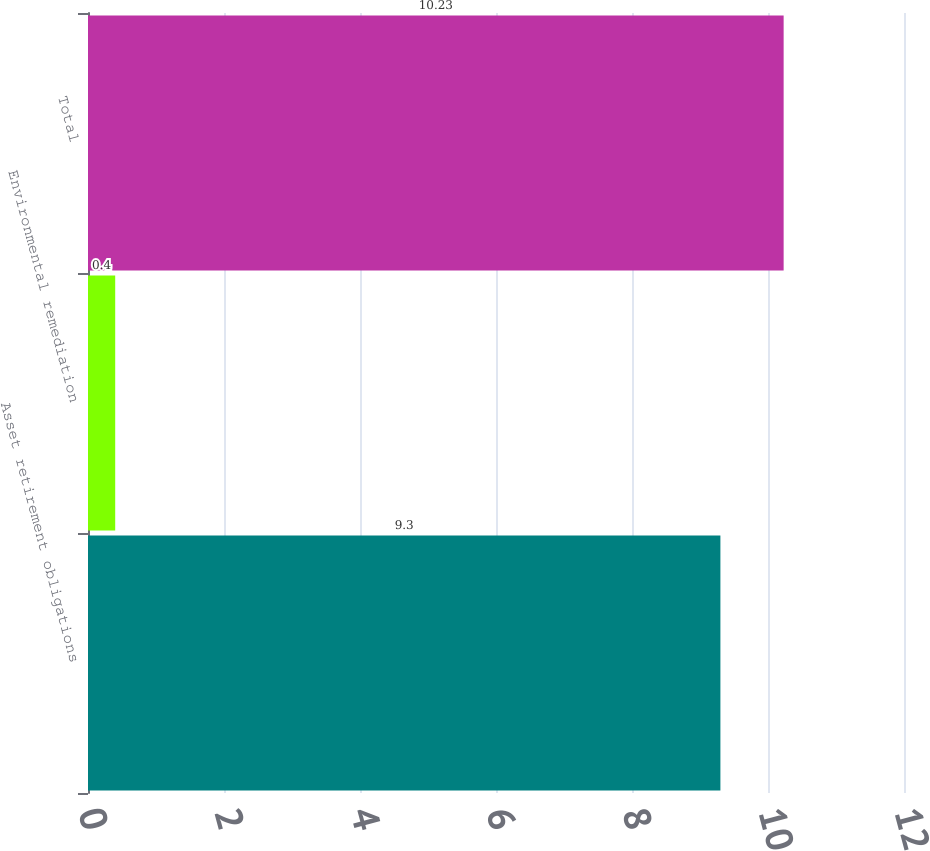Convert chart to OTSL. <chart><loc_0><loc_0><loc_500><loc_500><bar_chart><fcel>Asset retirement obligations<fcel>Environmental remediation<fcel>Total<nl><fcel>9.3<fcel>0.4<fcel>10.23<nl></chart> 